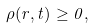<formula> <loc_0><loc_0><loc_500><loc_500>\rho ( r , t ) \geq 0 ,</formula> 